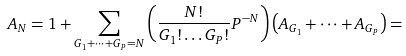<formula> <loc_0><loc_0><loc_500><loc_500>A _ { N } = 1 + \sum _ { G _ { 1 } + \dots + G _ { P } = N } \left ( \frac { N ! } { G _ { 1 } ! \dots G _ { P } ! } P ^ { - N } \right ) \left ( A _ { G _ { 1 } } + \dots + A _ { G _ { P } } \right ) =</formula> 